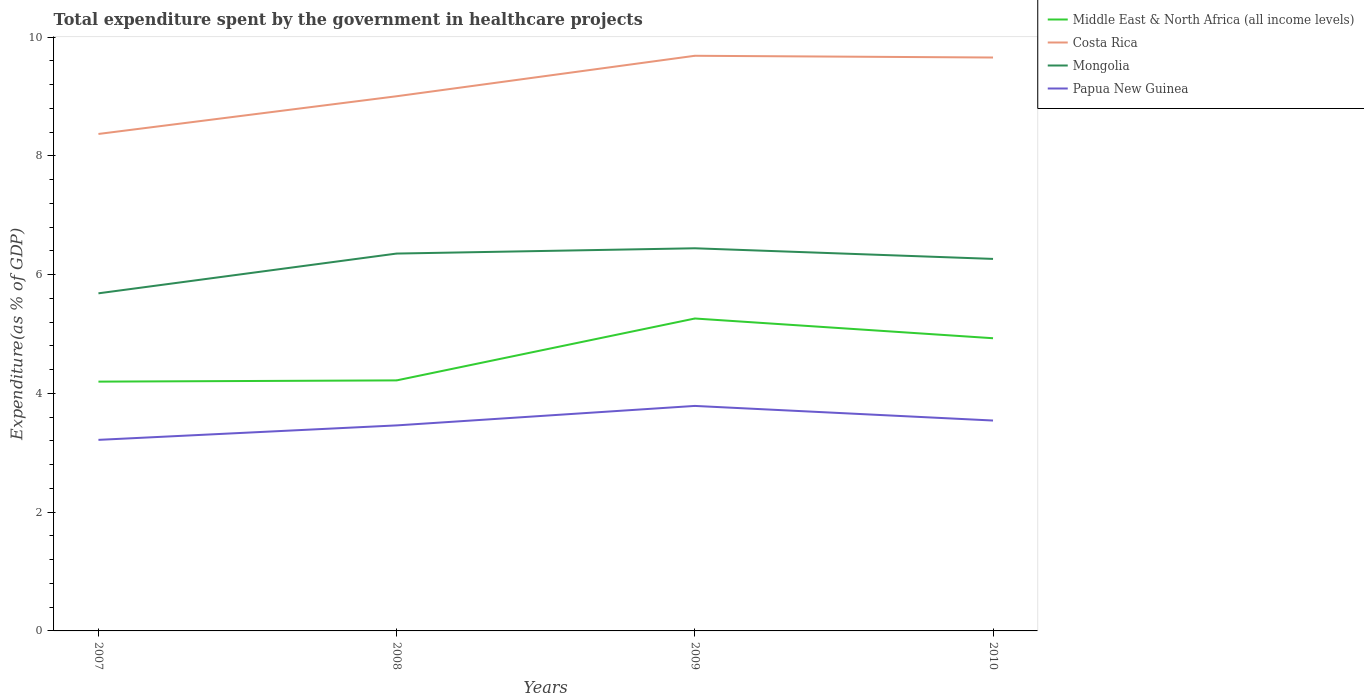Does the line corresponding to Papua New Guinea intersect with the line corresponding to Middle East & North Africa (all income levels)?
Provide a succinct answer. No. Is the number of lines equal to the number of legend labels?
Provide a succinct answer. Yes. Across all years, what is the maximum total expenditure spent by the government in healthcare projects in Middle East & North Africa (all income levels)?
Provide a short and direct response. 4.2. In which year was the total expenditure spent by the government in healthcare projects in Papua New Guinea maximum?
Give a very brief answer. 2007. What is the total total expenditure spent by the government in healthcare projects in Middle East & North Africa (all income levels) in the graph?
Make the answer very short. 0.33. What is the difference between the highest and the second highest total expenditure spent by the government in healthcare projects in Middle East & North Africa (all income levels)?
Ensure brevity in your answer.  1.06. How many lines are there?
Your answer should be very brief. 4. How many years are there in the graph?
Provide a succinct answer. 4. What is the difference between two consecutive major ticks on the Y-axis?
Offer a very short reply. 2. Does the graph contain any zero values?
Keep it short and to the point. No. Where does the legend appear in the graph?
Ensure brevity in your answer.  Top right. How many legend labels are there?
Your answer should be compact. 4. How are the legend labels stacked?
Your answer should be compact. Vertical. What is the title of the graph?
Your response must be concise. Total expenditure spent by the government in healthcare projects. Does "Low & middle income" appear as one of the legend labels in the graph?
Make the answer very short. No. What is the label or title of the X-axis?
Your response must be concise. Years. What is the label or title of the Y-axis?
Offer a terse response. Expenditure(as % of GDP). What is the Expenditure(as % of GDP) of Middle East & North Africa (all income levels) in 2007?
Make the answer very short. 4.2. What is the Expenditure(as % of GDP) in Costa Rica in 2007?
Give a very brief answer. 8.37. What is the Expenditure(as % of GDP) of Mongolia in 2007?
Give a very brief answer. 5.69. What is the Expenditure(as % of GDP) in Papua New Guinea in 2007?
Offer a very short reply. 3.22. What is the Expenditure(as % of GDP) of Middle East & North Africa (all income levels) in 2008?
Your answer should be very brief. 4.22. What is the Expenditure(as % of GDP) in Costa Rica in 2008?
Give a very brief answer. 9.01. What is the Expenditure(as % of GDP) in Mongolia in 2008?
Ensure brevity in your answer.  6.36. What is the Expenditure(as % of GDP) of Papua New Guinea in 2008?
Give a very brief answer. 3.46. What is the Expenditure(as % of GDP) of Middle East & North Africa (all income levels) in 2009?
Provide a short and direct response. 5.26. What is the Expenditure(as % of GDP) in Costa Rica in 2009?
Offer a terse response. 9.69. What is the Expenditure(as % of GDP) of Mongolia in 2009?
Make the answer very short. 6.44. What is the Expenditure(as % of GDP) of Papua New Guinea in 2009?
Keep it short and to the point. 3.79. What is the Expenditure(as % of GDP) of Middle East & North Africa (all income levels) in 2010?
Ensure brevity in your answer.  4.93. What is the Expenditure(as % of GDP) in Costa Rica in 2010?
Provide a succinct answer. 9.66. What is the Expenditure(as % of GDP) of Mongolia in 2010?
Your response must be concise. 6.27. What is the Expenditure(as % of GDP) of Papua New Guinea in 2010?
Provide a succinct answer. 3.54. Across all years, what is the maximum Expenditure(as % of GDP) of Middle East & North Africa (all income levels)?
Your response must be concise. 5.26. Across all years, what is the maximum Expenditure(as % of GDP) of Costa Rica?
Provide a short and direct response. 9.69. Across all years, what is the maximum Expenditure(as % of GDP) of Mongolia?
Keep it short and to the point. 6.44. Across all years, what is the maximum Expenditure(as % of GDP) in Papua New Guinea?
Provide a succinct answer. 3.79. Across all years, what is the minimum Expenditure(as % of GDP) in Middle East & North Africa (all income levels)?
Your answer should be very brief. 4.2. Across all years, what is the minimum Expenditure(as % of GDP) of Costa Rica?
Ensure brevity in your answer.  8.37. Across all years, what is the minimum Expenditure(as % of GDP) in Mongolia?
Make the answer very short. 5.69. Across all years, what is the minimum Expenditure(as % of GDP) in Papua New Guinea?
Your response must be concise. 3.22. What is the total Expenditure(as % of GDP) of Middle East & North Africa (all income levels) in the graph?
Provide a short and direct response. 18.61. What is the total Expenditure(as % of GDP) of Costa Rica in the graph?
Provide a succinct answer. 36.72. What is the total Expenditure(as % of GDP) in Mongolia in the graph?
Your response must be concise. 24.75. What is the total Expenditure(as % of GDP) in Papua New Guinea in the graph?
Offer a terse response. 14.01. What is the difference between the Expenditure(as % of GDP) of Middle East & North Africa (all income levels) in 2007 and that in 2008?
Your answer should be very brief. -0.02. What is the difference between the Expenditure(as % of GDP) in Costa Rica in 2007 and that in 2008?
Make the answer very short. -0.64. What is the difference between the Expenditure(as % of GDP) in Mongolia in 2007 and that in 2008?
Give a very brief answer. -0.67. What is the difference between the Expenditure(as % of GDP) in Papua New Guinea in 2007 and that in 2008?
Offer a very short reply. -0.24. What is the difference between the Expenditure(as % of GDP) of Middle East & North Africa (all income levels) in 2007 and that in 2009?
Your response must be concise. -1.06. What is the difference between the Expenditure(as % of GDP) in Costa Rica in 2007 and that in 2009?
Your response must be concise. -1.32. What is the difference between the Expenditure(as % of GDP) of Mongolia in 2007 and that in 2009?
Your response must be concise. -0.76. What is the difference between the Expenditure(as % of GDP) in Papua New Guinea in 2007 and that in 2009?
Provide a short and direct response. -0.57. What is the difference between the Expenditure(as % of GDP) of Middle East & North Africa (all income levels) in 2007 and that in 2010?
Make the answer very short. -0.73. What is the difference between the Expenditure(as % of GDP) of Costa Rica in 2007 and that in 2010?
Ensure brevity in your answer.  -1.29. What is the difference between the Expenditure(as % of GDP) of Mongolia in 2007 and that in 2010?
Offer a terse response. -0.58. What is the difference between the Expenditure(as % of GDP) in Papua New Guinea in 2007 and that in 2010?
Provide a short and direct response. -0.33. What is the difference between the Expenditure(as % of GDP) in Middle East & North Africa (all income levels) in 2008 and that in 2009?
Ensure brevity in your answer.  -1.04. What is the difference between the Expenditure(as % of GDP) in Costa Rica in 2008 and that in 2009?
Ensure brevity in your answer.  -0.68. What is the difference between the Expenditure(as % of GDP) in Mongolia in 2008 and that in 2009?
Offer a terse response. -0.09. What is the difference between the Expenditure(as % of GDP) in Papua New Guinea in 2008 and that in 2009?
Give a very brief answer. -0.33. What is the difference between the Expenditure(as % of GDP) in Middle East & North Africa (all income levels) in 2008 and that in 2010?
Your answer should be compact. -0.71. What is the difference between the Expenditure(as % of GDP) of Costa Rica in 2008 and that in 2010?
Ensure brevity in your answer.  -0.65. What is the difference between the Expenditure(as % of GDP) of Mongolia in 2008 and that in 2010?
Keep it short and to the point. 0.09. What is the difference between the Expenditure(as % of GDP) in Papua New Guinea in 2008 and that in 2010?
Your answer should be very brief. -0.08. What is the difference between the Expenditure(as % of GDP) of Middle East & North Africa (all income levels) in 2009 and that in 2010?
Provide a short and direct response. 0.33. What is the difference between the Expenditure(as % of GDP) in Costa Rica in 2009 and that in 2010?
Give a very brief answer. 0.03. What is the difference between the Expenditure(as % of GDP) of Mongolia in 2009 and that in 2010?
Offer a terse response. 0.18. What is the difference between the Expenditure(as % of GDP) of Papua New Guinea in 2009 and that in 2010?
Your response must be concise. 0.25. What is the difference between the Expenditure(as % of GDP) in Middle East & North Africa (all income levels) in 2007 and the Expenditure(as % of GDP) in Costa Rica in 2008?
Your response must be concise. -4.81. What is the difference between the Expenditure(as % of GDP) in Middle East & North Africa (all income levels) in 2007 and the Expenditure(as % of GDP) in Mongolia in 2008?
Offer a very short reply. -2.16. What is the difference between the Expenditure(as % of GDP) of Middle East & North Africa (all income levels) in 2007 and the Expenditure(as % of GDP) of Papua New Guinea in 2008?
Your answer should be very brief. 0.74. What is the difference between the Expenditure(as % of GDP) in Costa Rica in 2007 and the Expenditure(as % of GDP) in Mongolia in 2008?
Give a very brief answer. 2.01. What is the difference between the Expenditure(as % of GDP) of Costa Rica in 2007 and the Expenditure(as % of GDP) of Papua New Guinea in 2008?
Keep it short and to the point. 4.91. What is the difference between the Expenditure(as % of GDP) of Mongolia in 2007 and the Expenditure(as % of GDP) of Papua New Guinea in 2008?
Ensure brevity in your answer.  2.22. What is the difference between the Expenditure(as % of GDP) in Middle East & North Africa (all income levels) in 2007 and the Expenditure(as % of GDP) in Costa Rica in 2009?
Your answer should be very brief. -5.49. What is the difference between the Expenditure(as % of GDP) of Middle East & North Africa (all income levels) in 2007 and the Expenditure(as % of GDP) of Mongolia in 2009?
Your answer should be compact. -2.25. What is the difference between the Expenditure(as % of GDP) of Middle East & North Africa (all income levels) in 2007 and the Expenditure(as % of GDP) of Papua New Guinea in 2009?
Give a very brief answer. 0.41. What is the difference between the Expenditure(as % of GDP) in Costa Rica in 2007 and the Expenditure(as % of GDP) in Mongolia in 2009?
Your response must be concise. 1.93. What is the difference between the Expenditure(as % of GDP) of Costa Rica in 2007 and the Expenditure(as % of GDP) of Papua New Guinea in 2009?
Provide a short and direct response. 4.58. What is the difference between the Expenditure(as % of GDP) of Mongolia in 2007 and the Expenditure(as % of GDP) of Papua New Guinea in 2009?
Make the answer very short. 1.9. What is the difference between the Expenditure(as % of GDP) of Middle East & North Africa (all income levels) in 2007 and the Expenditure(as % of GDP) of Costa Rica in 2010?
Your response must be concise. -5.46. What is the difference between the Expenditure(as % of GDP) in Middle East & North Africa (all income levels) in 2007 and the Expenditure(as % of GDP) in Mongolia in 2010?
Give a very brief answer. -2.07. What is the difference between the Expenditure(as % of GDP) in Middle East & North Africa (all income levels) in 2007 and the Expenditure(as % of GDP) in Papua New Guinea in 2010?
Give a very brief answer. 0.66. What is the difference between the Expenditure(as % of GDP) of Costa Rica in 2007 and the Expenditure(as % of GDP) of Mongolia in 2010?
Keep it short and to the point. 2.1. What is the difference between the Expenditure(as % of GDP) of Costa Rica in 2007 and the Expenditure(as % of GDP) of Papua New Guinea in 2010?
Your answer should be compact. 4.83. What is the difference between the Expenditure(as % of GDP) of Mongolia in 2007 and the Expenditure(as % of GDP) of Papua New Guinea in 2010?
Give a very brief answer. 2.14. What is the difference between the Expenditure(as % of GDP) of Middle East & North Africa (all income levels) in 2008 and the Expenditure(as % of GDP) of Costa Rica in 2009?
Give a very brief answer. -5.47. What is the difference between the Expenditure(as % of GDP) in Middle East & North Africa (all income levels) in 2008 and the Expenditure(as % of GDP) in Mongolia in 2009?
Your answer should be compact. -2.22. What is the difference between the Expenditure(as % of GDP) of Middle East & North Africa (all income levels) in 2008 and the Expenditure(as % of GDP) of Papua New Guinea in 2009?
Your answer should be very brief. 0.43. What is the difference between the Expenditure(as % of GDP) in Costa Rica in 2008 and the Expenditure(as % of GDP) in Mongolia in 2009?
Offer a terse response. 2.56. What is the difference between the Expenditure(as % of GDP) of Costa Rica in 2008 and the Expenditure(as % of GDP) of Papua New Guinea in 2009?
Give a very brief answer. 5.22. What is the difference between the Expenditure(as % of GDP) in Mongolia in 2008 and the Expenditure(as % of GDP) in Papua New Guinea in 2009?
Your answer should be very brief. 2.57. What is the difference between the Expenditure(as % of GDP) in Middle East & North Africa (all income levels) in 2008 and the Expenditure(as % of GDP) in Costa Rica in 2010?
Offer a terse response. -5.44. What is the difference between the Expenditure(as % of GDP) of Middle East & North Africa (all income levels) in 2008 and the Expenditure(as % of GDP) of Mongolia in 2010?
Your answer should be compact. -2.05. What is the difference between the Expenditure(as % of GDP) of Middle East & North Africa (all income levels) in 2008 and the Expenditure(as % of GDP) of Papua New Guinea in 2010?
Provide a short and direct response. 0.68. What is the difference between the Expenditure(as % of GDP) of Costa Rica in 2008 and the Expenditure(as % of GDP) of Mongolia in 2010?
Make the answer very short. 2.74. What is the difference between the Expenditure(as % of GDP) of Costa Rica in 2008 and the Expenditure(as % of GDP) of Papua New Guinea in 2010?
Your answer should be compact. 5.46. What is the difference between the Expenditure(as % of GDP) of Mongolia in 2008 and the Expenditure(as % of GDP) of Papua New Guinea in 2010?
Your response must be concise. 2.81. What is the difference between the Expenditure(as % of GDP) in Middle East & North Africa (all income levels) in 2009 and the Expenditure(as % of GDP) in Costa Rica in 2010?
Provide a succinct answer. -4.4. What is the difference between the Expenditure(as % of GDP) of Middle East & North Africa (all income levels) in 2009 and the Expenditure(as % of GDP) of Mongolia in 2010?
Your answer should be very brief. -1. What is the difference between the Expenditure(as % of GDP) of Middle East & North Africa (all income levels) in 2009 and the Expenditure(as % of GDP) of Papua New Guinea in 2010?
Ensure brevity in your answer.  1.72. What is the difference between the Expenditure(as % of GDP) in Costa Rica in 2009 and the Expenditure(as % of GDP) in Mongolia in 2010?
Offer a very short reply. 3.42. What is the difference between the Expenditure(as % of GDP) of Costa Rica in 2009 and the Expenditure(as % of GDP) of Papua New Guinea in 2010?
Your response must be concise. 6.14. What is the difference between the Expenditure(as % of GDP) in Mongolia in 2009 and the Expenditure(as % of GDP) in Papua New Guinea in 2010?
Give a very brief answer. 2.9. What is the average Expenditure(as % of GDP) of Middle East & North Africa (all income levels) per year?
Offer a very short reply. 4.65. What is the average Expenditure(as % of GDP) in Costa Rica per year?
Keep it short and to the point. 9.18. What is the average Expenditure(as % of GDP) in Mongolia per year?
Your answer should be very brief. 6.19. What is the average Expenditure(as % of GDP) in Papua New Guinea per year?
Your answer should be very brief. 3.5. In the year 2007, what is the difference between the Expenditure(as % of GDP) in Middle East & North Africa (all income levels) and Expenditure(as % of GDP) in Costa Rica?
Make the answer very short. -4.17. In the year 2007, what is the difference between the Expenditure(as % of GDP) in Middle East & North Africa (all income levels) and Expenditure(as % of GDP) in Mongolia?
Give a very brief answer. -1.49. In the year 2007, what is the difference between the Expenditure(as % of GDP) of Middle East & North Africa (all income levels) and Expenditure(as % of GDP) of Papua New Guinea?
Ensure brevity in your answer.  0.98. In the year 2007, what is the difference between the Expenditure(as % of GDP) in Costa Rica and Expenditure(as % of GDP) in Mongolia?
Your response must be concise. 2.68. In the year 2007, what is the difference between the Expenditure(as % of GDP) in Costa Rica and Expenditure(as % of GDP) in Papua New Guinea?
Offer a very short reply. 5.15. In the year 2007, what is the difference between the Expenditure(as % of GDP) in Mongolia and Expenditure(as % of GDP) in Papua New Guinea?
Offer a terse response. 2.47. In the year 2008, what is the difference between the Expenditure(as % of GDP) in Middle East & North Africa (all income levels) and Expenditure(as % of GDP) in Costa Rica?
Provide a succinct answer. -4.79. In the year 2008, what is the difference between the Expenditure(as % of GDP) of Middle East & North Africa (all income levels) and Expenditure(as % of GDP) of Mongolia?
Give a very brief answer. -2.14. In the year 2008, what is the difference between the Expenditure(as % of GDP) of Middle East & North Africa (all income levels) and Expenditure(as % of GDP) of Papua New Guinea?
Provide a succinct answer. 0.76. In the year 2008, what is the difference between the Expenditure(as % of GDP) in Costa Rica and Expenditure(as % of GDP) in Mongolia?
Offer a very short reply. 2.65. In the year 2008, what is the difference between the Expenditure(as % of GDP) of Costa Rica and Expenditure(as % of GDP) of Papua New Guinea?
Your answer should be compact. 5.54. In the year 2008, what is the difference between the Expenditure(as % of GDP) in Mongolia and Expenditure(as % of GDP) in Papua New Guinea?
Provide a short and direct response. 2.89. In the year 2009, what is the difference between the Expenditure(as % of GDP) in Middle East & North Africa (all income levels) and Expenditure(as % of GDP) in Costa Rica?
Your answer should be compact. -4.42. In the year 2009, what is the difference between the Expenditure(as % of GDP) of Middle East & North Africa (all income levels) and Expenditure(as % of GDP) of Mongolia?
Provide a short and direct response. -1.18. In the year 2009, what is the difference between the Expenditure(as % of GDP) of Middle East & North Africa (all income levels) and Expenditure(as % of GDP) of Papua New Guinea?
Your answer should be compact. 1.47. In the year 2009, what is the difference between the Expenditure(as % of GDP) of Costa Rica and Expenditure(as % of GDP) of Mongolia?
Offer a very short reply. 3.24. In the year 2009, what is the difference between the Expenditure(as % of GDP) in Costa Rica and Expenditure(as % of GDP) in Papua New Guinea?
Keep it short and to the point. 5.9. In the year 2009, what is the difference between the Expenditure(as % of GDP) in Mongolia and Expenditure(as % of GDP) in Papua New Guinea?
Ensure brevity in your answer.  2.65. In the year 2010, what is the difference between the Expenditure(as % of GDP) of Middle East & North Africa (all income levels) and Expenditure(as % of GDP) of Costa Rica?
Your answer should be compact. -4.73. In the year 2010, what is the difference between the Expenditure(as % of GDP) of Middle East & North Africa (all income levels) and Expenditure(as % of GDP) of Mongolia?
Make the answer very short. -1.34. In the year 2010, what is the difference between the Expenditure(as % of GDP) of Middle East & North Africa (all income levels) and Expenditure(as % of GDP) of Papua New Guinea?
Offer a very short reply. 1.39. In the year 2010, what is the difference between the Expenditure(as % of GDP) in Costa Rica and Expenditure(as % of GDP) in Mongolia?
Make the answer very short. 3.39. In the year 2010, what is the difference between the Expenditure(as % of GDP) of Costa Rica and Expenditure(as % of GDP) of Papua New Guinea?
Provide a succinct answer. 6.11. In the year 2010, what is the difference between the Expenditure(as % of GDP) of Mongolia and Expenditure(as % of GDP) of Papua New Guinea?
Ensure brevity in your answer.  2.72. What is the ratio of the Expenditure(as % of GDP) in Middle East & North Africa (all income levels) in 2007 to that in 2008?
Your response must be concise. 1. What is the ratio of the Expenditure(as % of GDP) of Costa Rica in 2007 to that in 2008?
Give a very brief answer. 0.93. What is the ratio of the Expenditure(as % of GDP) in Mongolia in 2007 to that in 2008?
Offer a terse response. 0.89. What is the ratio of the Expenditure(as % of GDP) in Papua New Guinea in 2007 to that in 2008?
Provide a succinct answer. 0.93. What is the ratio of the Expenditure(as % of GDP) of Middle East & North Africa (all income levels) in 2007 to that in 2009?
Make the answer very short. 0.8. What is the ratio of the Expenditure(as % of GDP) of Costa Rica in 2007 to that in 2009?
Provide a succinct answer. 0.86. What is the ratio of the Expenditure(as % of GDP) of Mongolia in 2007 to that in 2009?
Keep it short and to the point. 0.88. What is the ratio of the Expenditure(as % of GDP) in Papua New Guinea in 2007 to that in 2009?
Give a very brief answer. 0.85. What is the ratio of the Expenditure(as % of GDP) in Middle East & North Africa (all income levels) in 2007 to that in 2010?
Your answer should be compact. 0.85. What is the ratio of the Expenditure(as % of GDP) in Costa Rica in 2007 to that in 2010?
Offer a terse response. 0.87. What is the ratio of the Expenditure(as % of GDP) of Mongolia in 2007 to that in 2010?
Keep it short and to the point. 0.91. What is the ratio of the Expenditure(as % of GDP) of Papua New Guinea in 2007 to that in 2010?
Your answer should be compact. 0.91. What is the ratio of the Expenditure(as % of GDP) in Middle East & North Africa (all income levels) in 2008 to that in 2009?
Make the answer very short. 0.8. What is the ratio of the Expenditure(as % of GDP) in Costa Rica in 2008 to that in 2009?
Offer a terse response. 0.93. What is the ratio of the Expenditure(as % of GDP) in Mongolia in 2008 to that in 2009?
Your answer should be compact. 0.99. What is the ratio of the Expenditure(as % of GDP) in Papua New Guinea in 2008 to that in 2009?
Provide a succinct answer. 0.91. What is the ratio of the Expenditure(as % of GDP) of Middle East & North Africa (all income levels) in 2008 to that in 2010?
Give a very brief answer. 0.86. What is the ratio of the Expenditure(as % of GDP) in Costa Rica in 2008 to that in 2010?
Give a very brief answer. 0.93. What is the ratio of the Expenditure(as % of GDP) of Mongolia in 2008 to that in 2010?
Give a very brief answer. 1.01. What is the ratio of the Expenditure(as % of GDP) of Papua New Guinea in 2008 to that in 2010?
Provide a succinct answer. 0.98. What is the ratio of the Expenditure(as % of GDP) in Middle East & North Africa (all income levels) in 2009 to that in 2010?
Offer a very short reply. 1.07. What is the ratio of the Expenditure(as % of GDP) of Mongolia in 2009 to that in 2010?
Keep it short and to the point. 1.03. What is the ratio of the Expenditure(as % of GDP) of Papua New Guinea in 2009 to that in 2010?
Offer a terse response. 1.07. What is the difference between the highest and the second highest Expenditure(as % of GDP) of Middle East & North Africa (all income levels)?
Ensure brevity in your answer.  0.33. What is the difference between the highest and the second highest Expenditure(as % of GDP) of Costa Rica?
Offer a very short reply. 0.03. What is the difference between the highest and the second highest Expenditure(as % of GDP) of Mongolia?
Provide a short and direct response. 0.09. What is the difference between the highest and the second highest Expenditure(as % of GDP) of Papua New Guinea?
Make the answer very short. 0.25. What is the difference between the highest and the lowest Expenditure(as % of GDP) of Middle East & North Africa (all income levels)?
Offer a very short reply. 1.06. What is the difference between the highest and the lowest Expenditure(as % of GDP) in Costa Rica?
Provide a succinct answer. 1.32. What is the difference between the highest and the lowest Expenditure(as % of GDP) in Mongolia?
Offer a terse response. 0.76. What is the difference between the highest and the lowest Expenditure(as % of GDP) in Papua New Guinea?
Your answer should be compact. 0.57. 